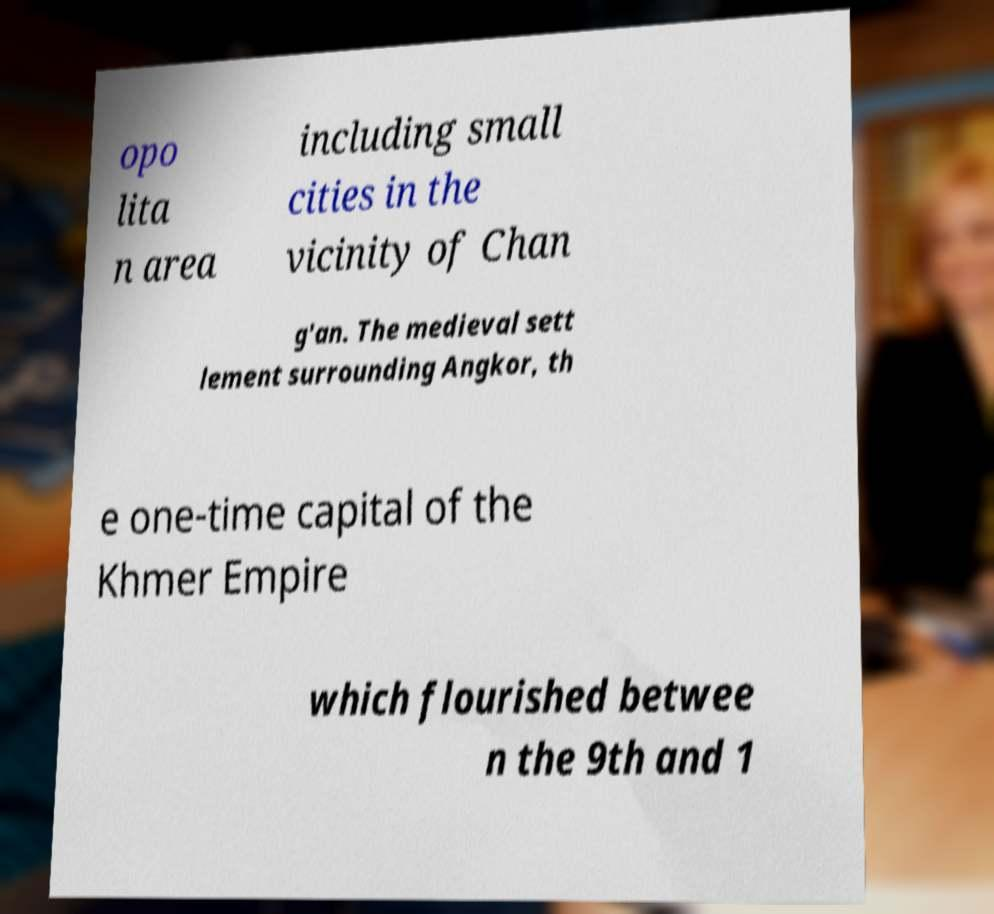Can you accurately transcribe the text from the provided image for me? opo lita n area including small cities in the vicinity of Chan g'an. The medieval sett lement surrounding Angkor, th e one-time capital of the Khmer Empire which flourished betwee n the 9th and 1 